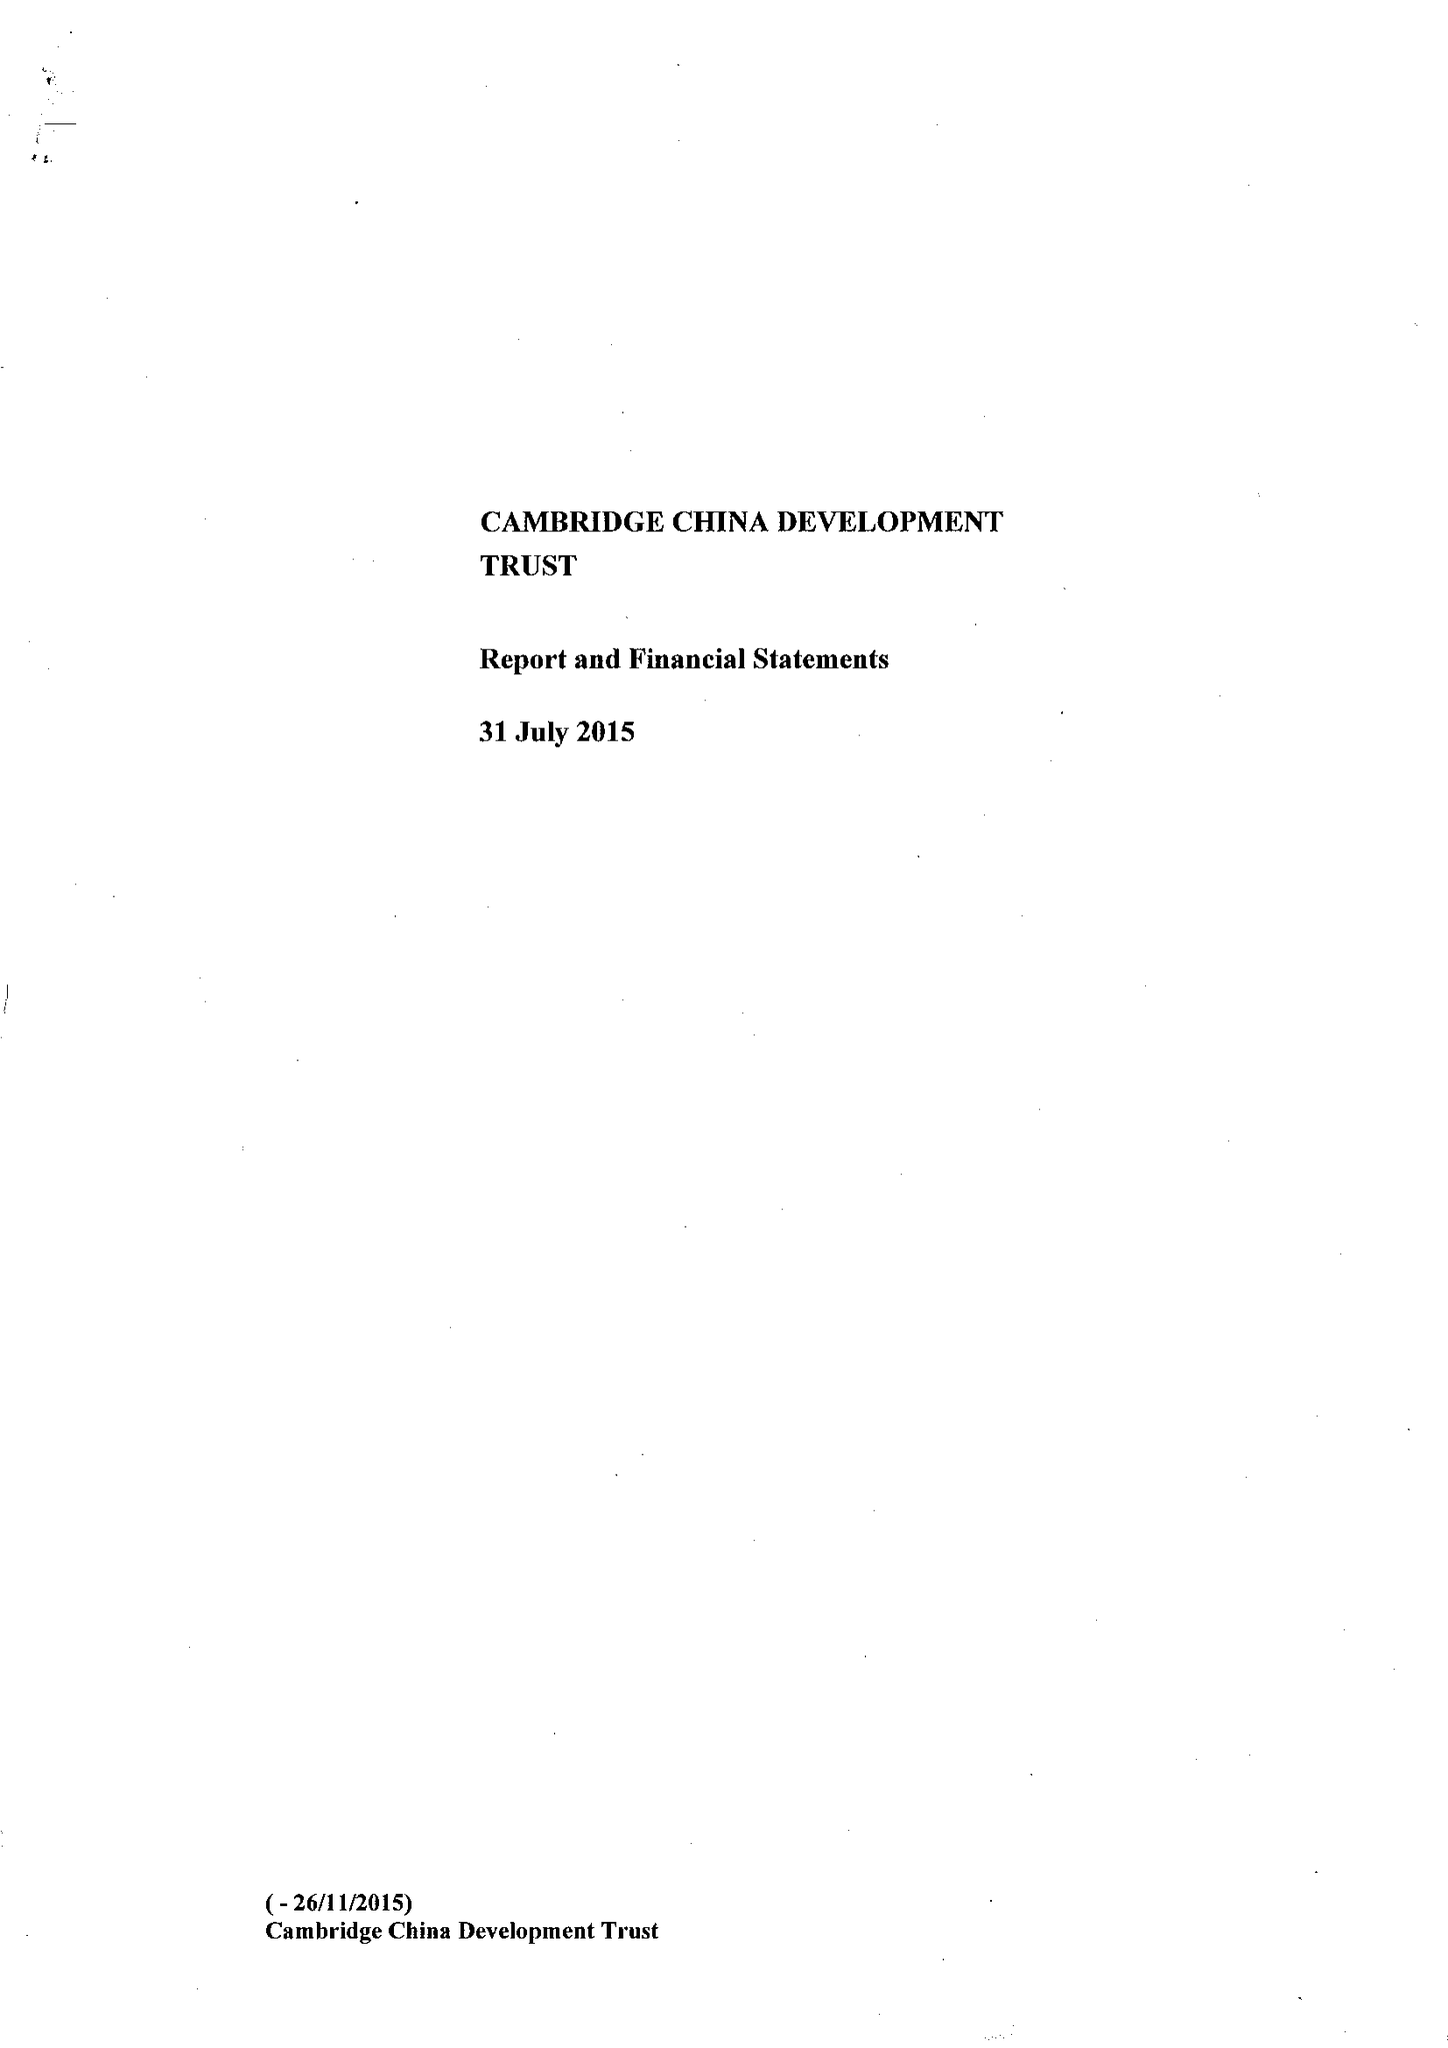What is the value for the address__street_line?
Answer the question using a single word or phrase. None 